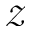Convert formula to latex. <formula><loc_0><loc_0><loc_500><loc_500>\mathcal { Z }</formula> 